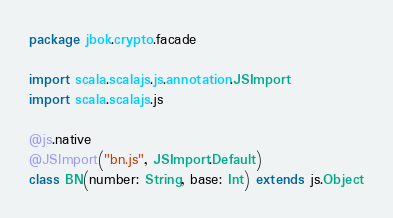Convert code to text. <code><loc_0><loc_0><loc_500><loc_500><_Scala_>package jbok.crypto.facade

import scala.scalajs.js.annotation.JSImport
import scala.scalajs.js

@js.native
@JSImport("bn.js", JSImport.Default)
class BN(number: String, base: Int) extends js.Object
</code> 